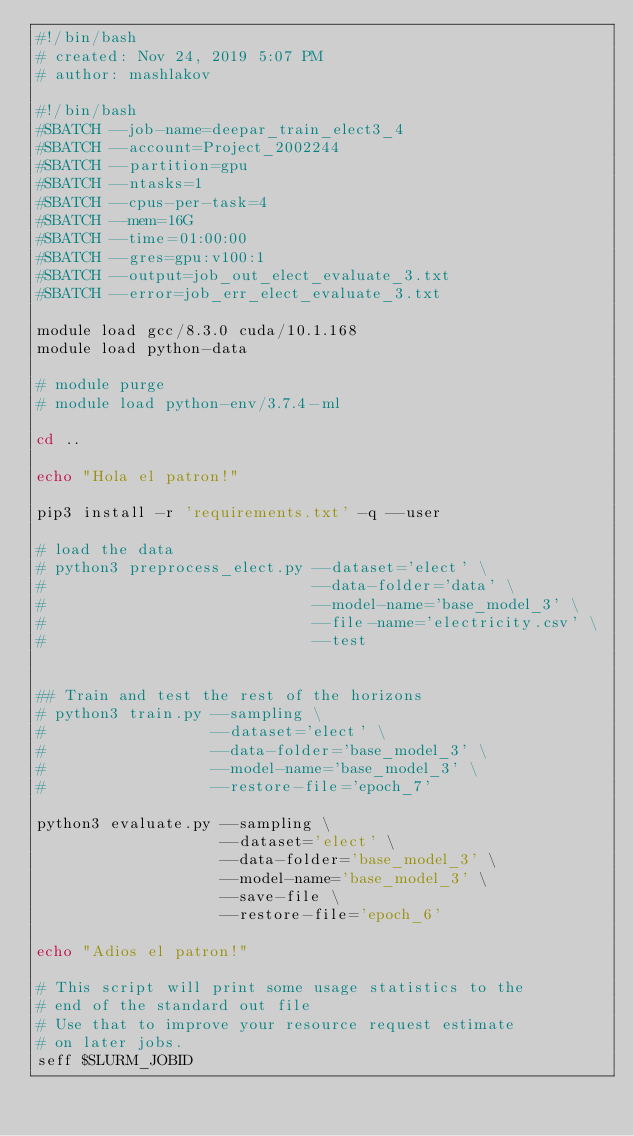Convert code to text. <code><loc_0><loc_0><loc_500><loc_500><_Bash_>#!/bin/bash
# created: Nov 24, 2019 5:07 PM
# author: mashlakov

#!/bin/bash
#SBATCH --job-name=deepar_train_elect3_4
#SBATCH --account=Project_2002244
#SBATCH --partition=gpu
#SBATCH --ntasks=1
#SBATCH --cpus-per-task=4
#SBATCH --mem=16G
#SBATCH --time=01:00:00
#SBATCH --gres=gpu:v100:1
#SBATCH --output=job_out_elect_evaluate_3.txt
#SBATCH --error=job_err_elect_evaluate_3.txt

module load gcc/8.3.0 cuda/10.1.168
module load python-data

# module purge
# module load python-env/3.7.4-ml

cd ..

echo "Hola el patron!"

pip3 install -r 'requirements.txt' -q --user

# load the data
# python3 preprocess_elect.py --dataset='elect' \
#                             --data-folder='data' \
#                             --model-name='base_model_3' \
#                             --file-name='electricity.csv' \
#                             --test
                            
                            
## Train and test the rest of the horizons 
# python3 train.py --sampling \
#                  --dataset='elect' \
#                  --data-folder='base_model_3' \
#                  --model-name='base_model_3' \
#                  --restore-file='epoch_7'
                  
python3 evaluate.py --sampling \
                    --dataset='elect' \
                    --data-folder='base_model_3' \
                    --model-name='base_model_3' \
                    --save-file \
                    --restore-file='epoch_6'

echo "Adios el patron!"

# This script will print some usage statistics to the
# end of the standard out file
# Use that to improve your resource request estimate
# on later jobs.
seff $SLURM_JOBID
</code> 